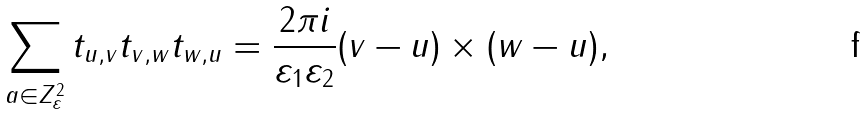Convert formula to latex. <formula><loc_0><loc_0><loc_500><loc_500>\sum _ { { a } \in { Z } _ { \varepsilon } ^ { 2 } } t _ { { u } , { v } } t _ { { v } , { w } } t _ { { w } , { u } } = \frac { 2 \pi i } { \varepsilon _ { 1 } \varepsilon _ { 2 } } ( { v } - { u } ) \times ( { w } - { u } ) ,</formula> 